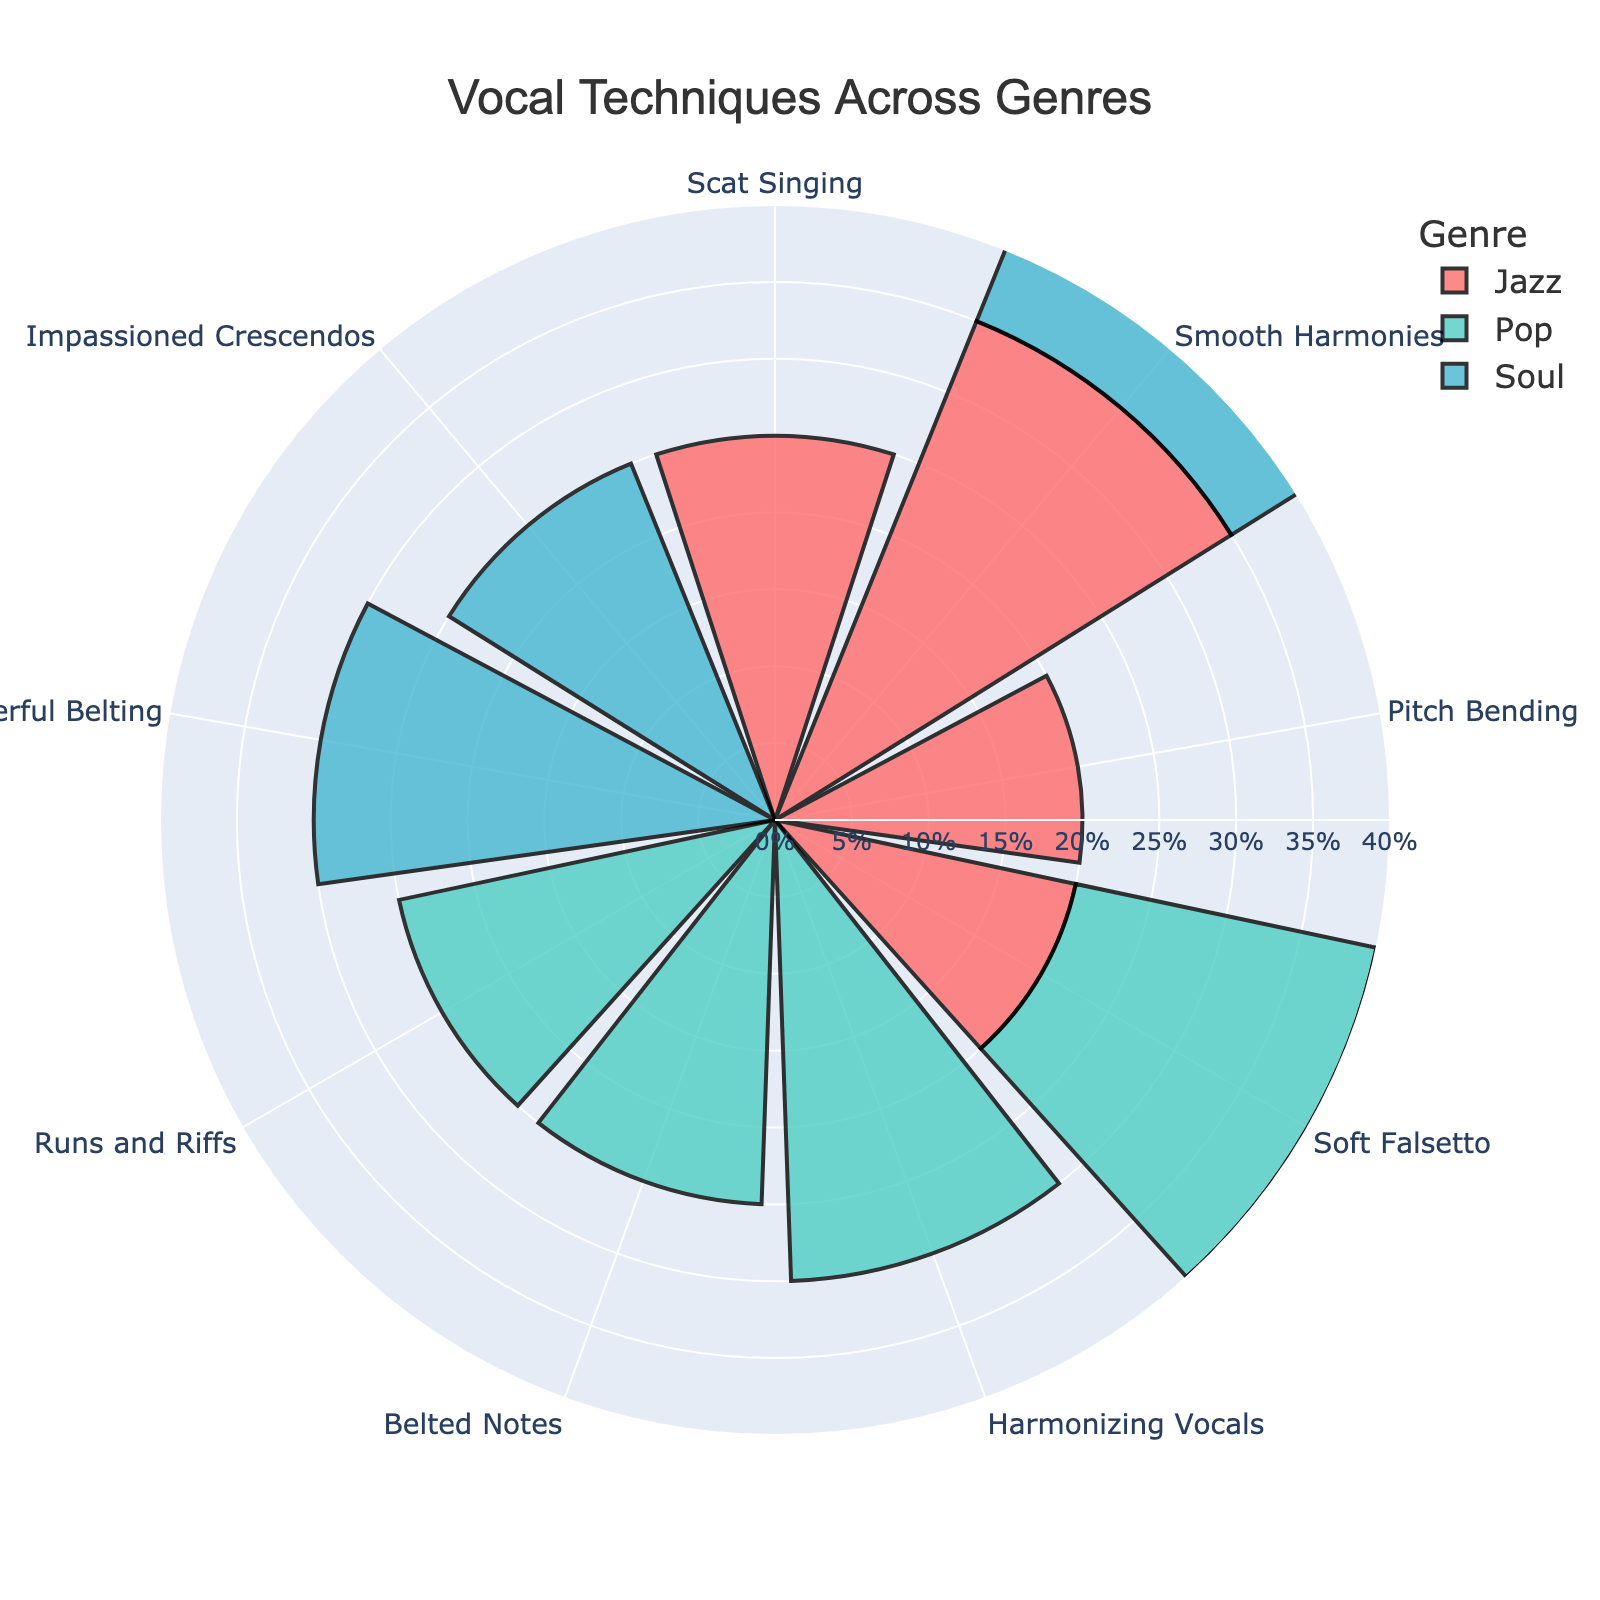What is the title of the chart? The title is usually positioned at the top of the figure, providing a summary of what the chart represents. In this case, the title is centered and states the main subject of the figure.
Answer: Vocal Techniques Across Genres How many genres are represented in the chart? By counting the different segments or colors in the figure's legend, which are labeled by genre, we can determine the number of distinct genres present.
Answer: 3 Which genre utilizes Harmonizing Vocals the most? Look for the segment labeled "Harmonizing Vocals" and observe which genre it appears under by checking the legend or the corresponding color and label.
Answer: Pop What is the combined percentage of Soft Falsetto usage across all genres? Locate the segments for Soft Falsetto in each genre (Pop, Jazz, and Soul), then sum their percentages: 20% from Pop, 20% from Jazz, and 20% from Soul.
Answer: 60% Which vocal technique is exclusive to the Jazz genre? Identify the vocal techniques listed under Jazz and compare them with the techniques listed for Pop and Soul to find the one that appears only in Jazz.
Answer: Scat Singing Which genre has the highest percentage for Smooth Harmonies? Check the segments labeled "Smooth Harmonies" in each genre and compare their percentages to find the highest one.
Answer: Jazz How does the percentage of Belted Notes in Pop compare to the percentage of Impassioned Crescendos in Soul? Identify the segments for Belted Notes in Pop and Impassioned Crescendos in Soul, then compare their percentages directly.
Answer: Equal What is the average percentage of Runs and Riffs in Pop and Pitch Bending in Jazz? Add the percentages of Runs and Riffs (25%) in Pop and Pitch Bending (20%) in Jazz, then divide by the number of values (2).
Answer: 22.5% Are there any vocal techniques that have exactly the same percentage across two different genres? Compare the percentages of each vocal technique in the genres. Soft Falsetto has the same percentage (20%) in Pop, Jazz, and Soul, but since the question is about exactly two, the valid pair can be Soft Falsetto (Pop and Jazz, or Pop and Soul, or Jazz and Soul).
Answer: Soft Falsetto 